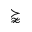<formula> <loc_0><loc_0><loc_500><loc_500>\succnapprox</formula> 